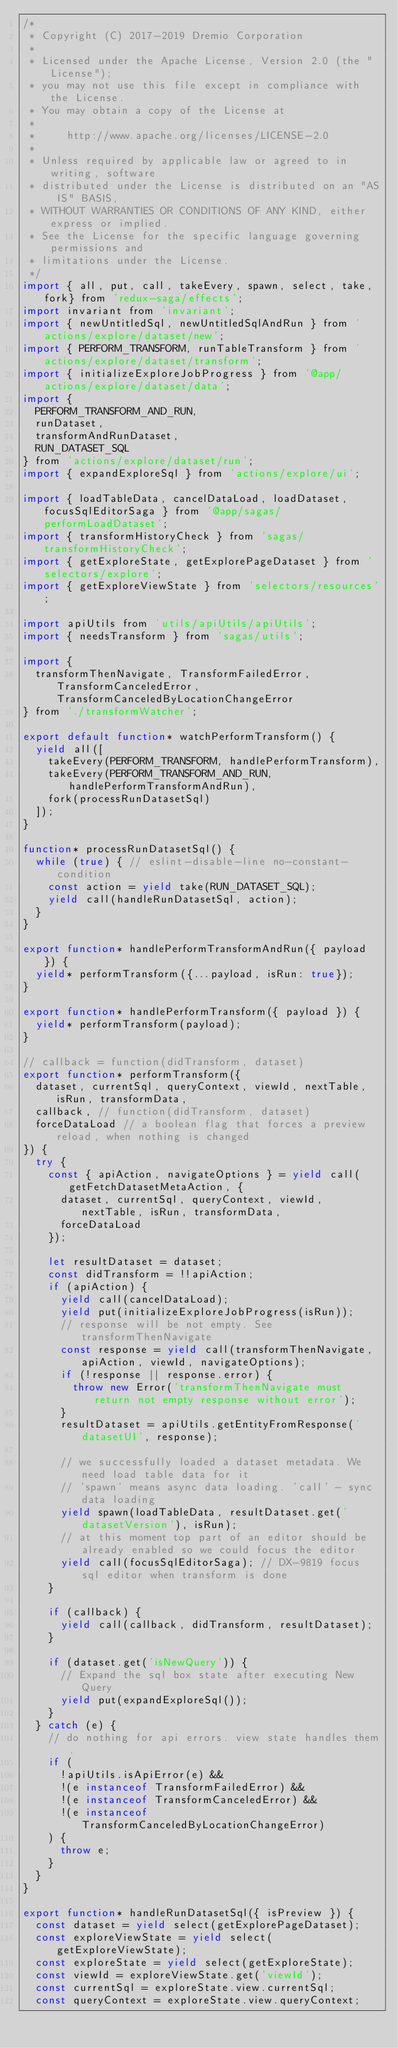<code> <loc_0><loc_0><loc_500><loc_500><_JavaScript_>/*
 * Copyright (C) 2017-2019 Dremio Corporation
 *
 * Licensed under the Apache License, Version 2.0 (the "License");
 * you may not use this file except in compliance with the License.
 * You may obtain a copy of the License at
 *
 *     http://www.apache.org/licenses/LICENSE-2.0
 *
 * Unless required by applicable law or agreed to in writing, software
 * distributed under the License is distributed on an "AS IS" BASIS,
 * WITHOUT WARRANTIES OR CONDITIONS OF ANY KIND, either express or implied.
 * See the License for the specific language governing permissions and
 * limitations under the License.
 */
import { all, put, call, takeEvery, spawn, select, take, fork} from 'redux-saga/effects';
import invariant from 'invariant';
import { newUntitledSql, newUntitledSqlAndRun } from 'actions/explore/dataset/new';
import { PERFORM_TRANSFORM, runTableTransform } from 'actions/explore/dataset/transform';
import { initializeExploreJobProgress } from '@app/actions/explore/dataset/data';
import {
  PERFORM_TRANSFORM_AND_RUN,
  runDataset,
  transformAndRunDataset,
  RUN_DATASET_SQL
} from 'actions/explore/dataset/run';
import { expandExploreSql } from 'actions/explore/ui';

import { loadTableData, cancelDataLoad, loadDataset, focusSqlEditorSaga } from '@app/sagas/performLoadDataset';
import { transformHistoryCheck } from 'sagas/transformHistoryCheck';
import { getExploreState, getExplorePageDataset } from 'selectors/explore';
import { getExploreViewState } from 'selectors/resources';

import apiUtils from 'utils/apiUtils/apiUtils';
import { needsTransform } from 'sagas/utils';

import {
  transformThenNavigate, TransformFailedError, TransformCanceledError, TransformCanceledByLocationChangeError
} from './transformWatcher';

export default function* watchPerformTransform() {
  yield all([
    takeEvery(PERFORM_TRANSFORM, handlePerformTransform),
    takeEvery(PERFORM_TRANSFORM_AND_RUN, handlePerformTransformAndRun),
    fork(processRunDatasetSql)
  ]);
}

function* processRunDatasetSql() {
  while (true) { // eslint-disable-line no-constant-condition
    const action = yield take(RUN_DATASET_SQL);
    yield call(handleRunDatasetSql, action);
  }
}

export function* handlePerformTransformAndRun({ payload }) {
  yield* performTransform({...payload, isRun: true});
}

export function* handlePerformTransform({ payload }) {
  yield* performTransform(payload);
}

// callback = function(didTransform, dataset)
export function* performTransform({
  dataset, currentSql, queryContext, viewId, nextTable, isRun, transformData,
  callback, // function(didTransform, dataset)
  forceDataLoad // a boolean flag that forces a preview reload, when nothing is changed
}) {
  try {
    const { apiAction, navigateOptions } = yield call(getFetchDatasetMetaAction, {
      dataset, currentSql, queryContext, viewId, nextTable, isRun, transformData,
      forceDataLoad
    });

    let resultDataset = dataset;
    const didTransform = !!apiAction;
    if (apiAction) {
      yield call(cancelDataLoad);
      yield put(initializeExploreJobProgress(isRun));
      // response will be not empty. See transformThenNavigate
      const response = yield call(transformThenNavigate, apiAction, viewId, navigateOptions);
      if (!response || response.error) {
        throw new Error('transformThenNavigate must return not empty response without error');
      }
      resultDataset = apiUtils.getEntityFromResponse('datasetUI', response);

      // we successfully loaded a dataset metadata. We need load table data for it
      // 'spawn' means async data loading. 'call' - sync data loading
      yield spawn(loadTableData, resultDataset.get('datasetVersion'), isRun);
      // at this moment top part of an editor should be already enabled so we could focus the editor
      yield call(focusSqlEditorSaga); // DX-9819 focus sql editor when transform is done
    }

    if (callback) {
      yield call(callback, didTransform, resultDataset);
    }

    if (dataset.get('isNewQuery')) {
      // Expand the sql box state after executing New Query
      yield put(expandExploreSql());
    }
  } catch (e) {
    // do nothing for api errors. view state handles them.
    if (
      !apiUtils.isApiError(e) &&
      !(e instanceof TransformFailedError) &&
      !(e instanceof TransformCanceledError) &&
      !(e instanceof TransformCanceledByLocationChangeError)
    ) {
      throw e;
    }
  }
}

export function* handleRunDatasetSql({ isPreview }) {
  const dataset = yield select(getExplorePageDataset);
  const exploreViewState = yield select(getExploreViewState);
  const exploreState = yield select(getExploreState);
  const viewId = exploreViewState.get('viewId');
  const currentSql = exploreState.view.currentSql;
  const queryContext = exploreState.view.queryContext;
</code> 